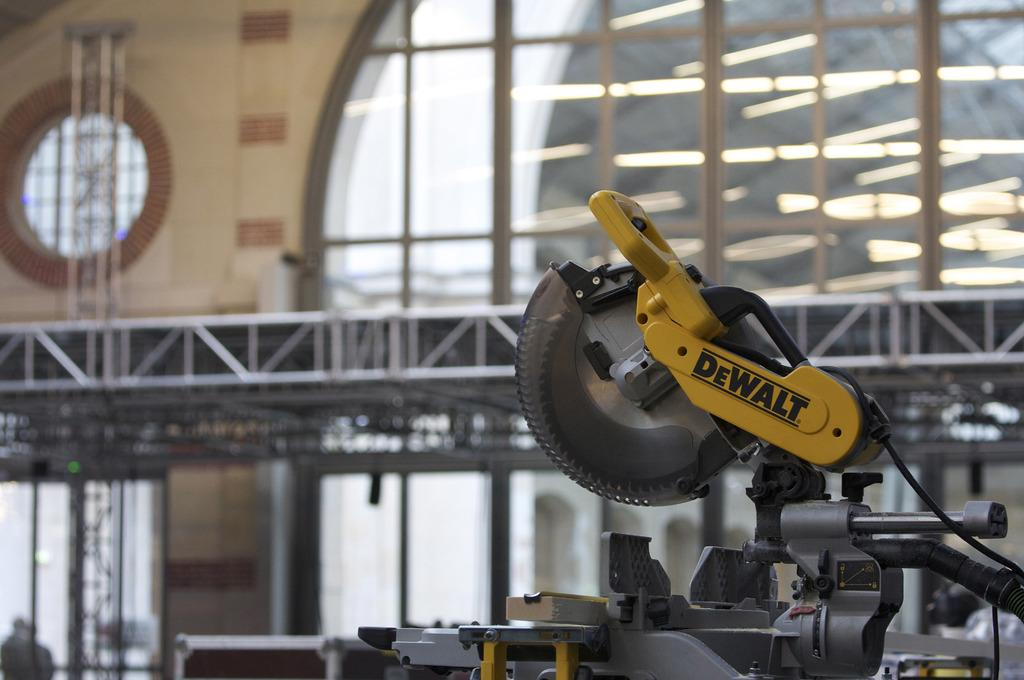Provide a one-sentence caption for the provided image. A Dewalt saw that is on a table in a room. 